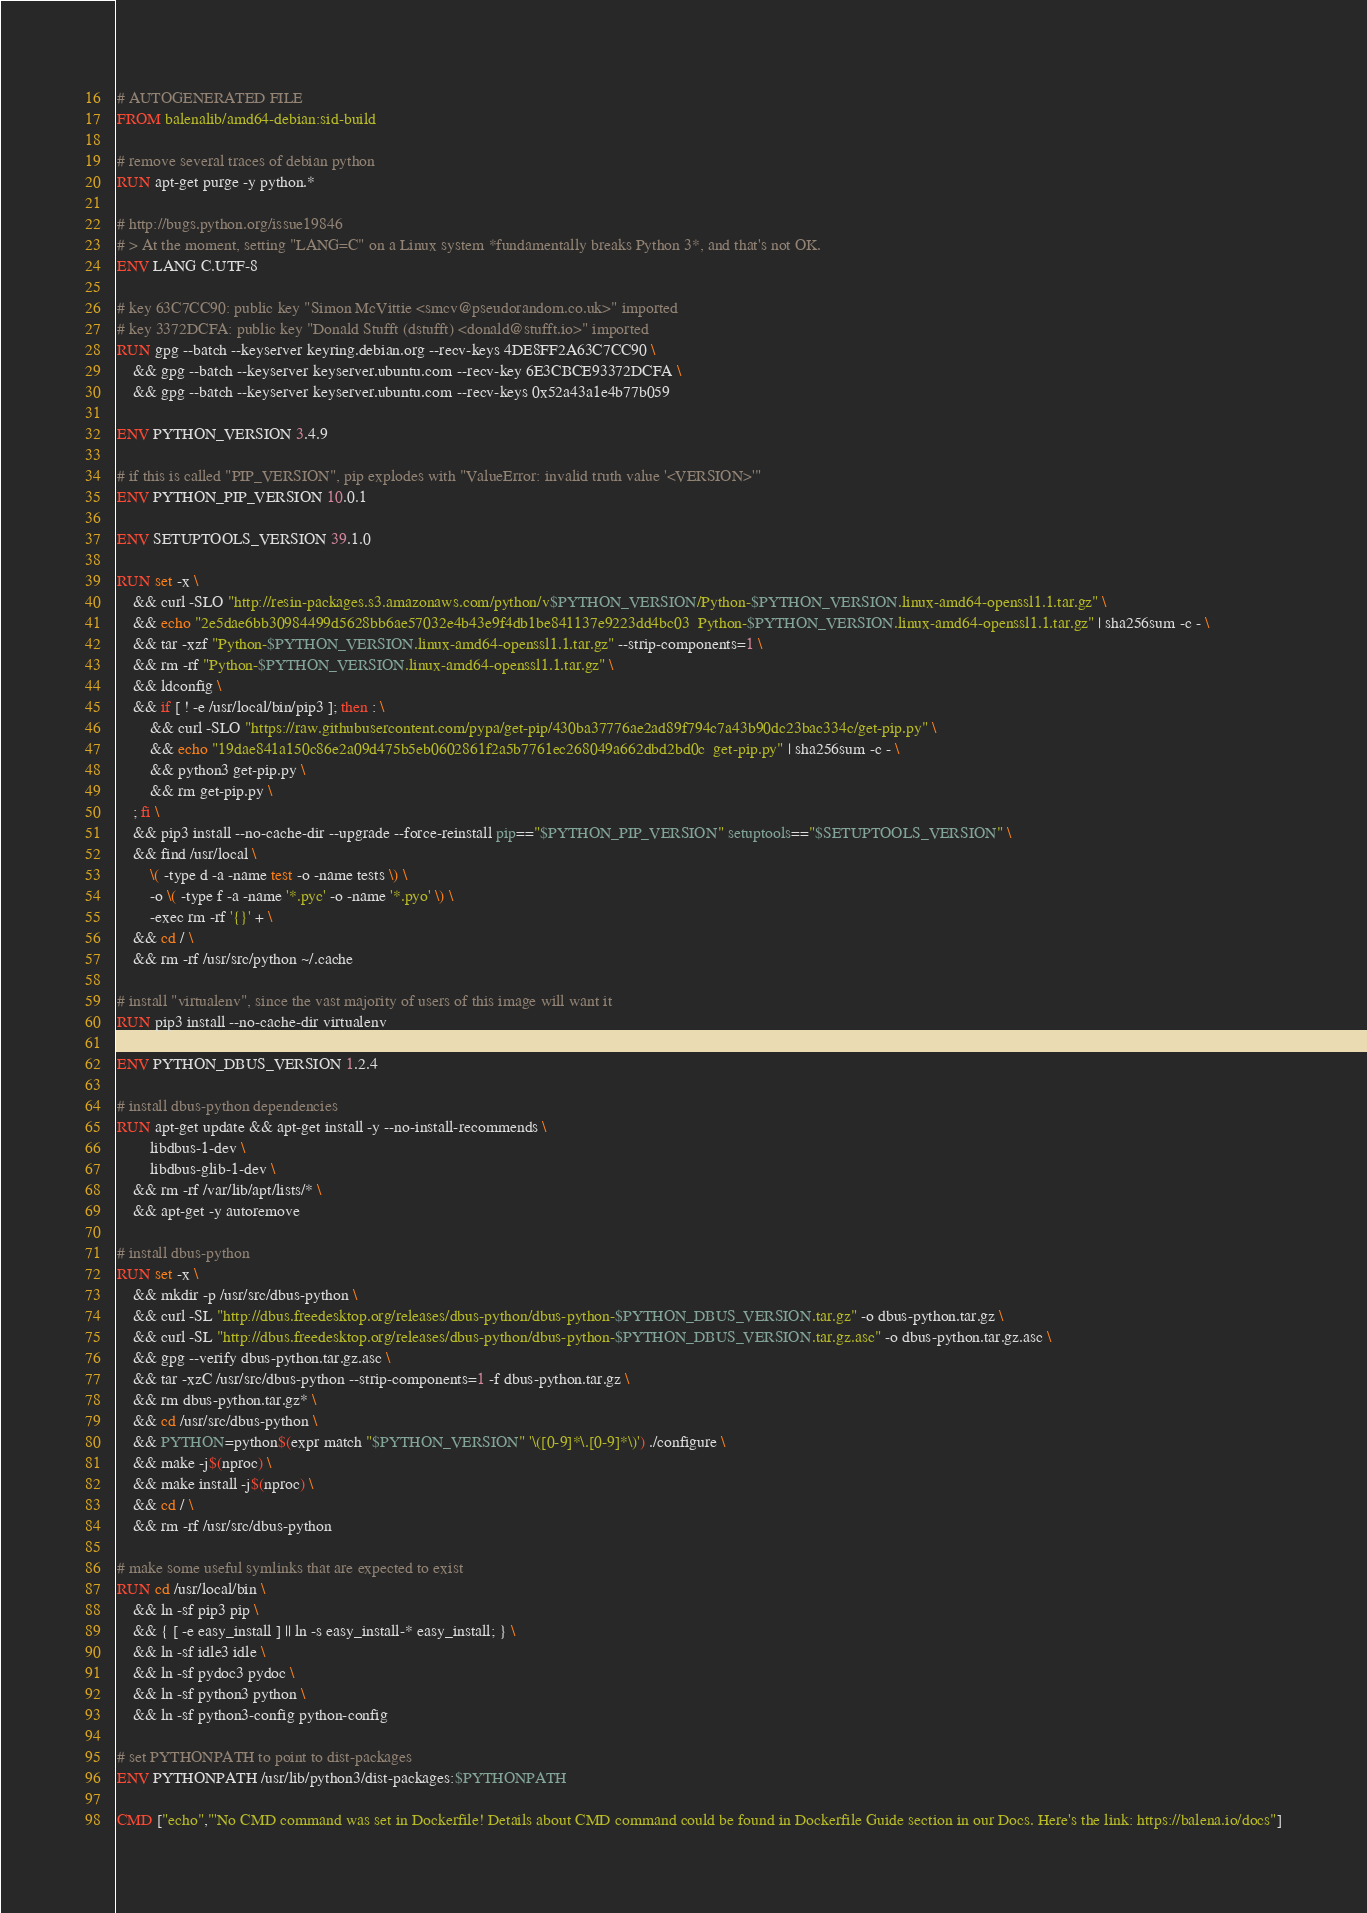<code> <loc_0><loc_0><loc_500><loc_500><_Dockerfile_># AUTOGENERATED FILE
FROM balenalib/amd64-debian:sid-build

# remove several traces of debian python
RUN apt-get purge -y python.*

# http://bugs.python.org/issue19846
# > At the moment, setting "LANG=C" on a Linux system *fundamentally breaks Python 3*, and that's not OK.
ENV LANG C.UTF-8

# key 63C7CC90: public key "Simon McVittie <smcv@pseudorandom.co.uk>" imported
# key 3372DCFA: public key "Donald Stufft (dstufft) <donald@stufft.io>" imported
RUN gpg --batch --keyserver keyring.debian.org --recv-keys 4DE8FF2A63C7CC90 \
	&& gpg --batch --keyserver keyserver.ubuntu.com --recv-key 6E3CBCE93372DCFA \
	&& gpg --batch --keyserver keyserver.ubuntu.com --recv-keys 0x52a43a1e4b77b059

ENV PYTHON_VERSION 3.4.9

# if this is called "PIP_VERSION", pip explodes with "ValueError: invalid truth value '<VERSION>'"
ENV PYTHON_PIP_VERSION 10.0.1

ENV SETUPTOOLS_VERSION 39.1.0

RUN set -x \
	&& curl -SLO "http://resin-packages.s3.amazonaws.com/python/v$PYTHON_VERSION/Python-$PYTHON_VERSION.linux-amd64-openssl1.1.tar.gz" \
	&& echo "2e5dae6bb30984499d5628bb6ae57032e4b43e9f4db1be841137e9223dd4bc03  Python-$PYTHON_VERSION.linux-amd64-openssl1.1.tar.gz" | sha256sum -c - \
	&& tar -xzf "Python-$PYTHON_VERSION.linux-amd64-openssl1.1.tar.gz" --strip-components=1 \
	&& rm -rf "Python-$PYTHON_VERSION.linux-amd64-openssl1.1.tar.gz" \
	&& ldconfig \
	&& if [ ! -e /usr/local/bin/pip3 ]; then : \
		&& curl -SLO "https://raw.githubusercontent.com/pypa/get-pip/430ba37776ae2ad89f794c7a43b90dc23bac334c/get-pip.py" \
		&& echo "19dae841a150c86e2a09d475b5eb0602861f2a5b7761ec268049a662dbd2bd0c  get-pip.py" | sha256sum -c - \
		&& python3 get-pip.py \
		&& rm get-pip.py \
	; fi \
	&& pip3 install --no-cache-dir --upgrade --force-reinstall pip=="$PYTHON_PIP_VERSION" setuptools=="$SETUPTOOLS_VERSION" \
	&& find /usr/local \
		\( -type d -a -name test -o -name tests \) \
		-o \( -type f -a -name '*.pyc' -o -name '*.pyo' \) \
		-exec rm -rf '{}' + \
	&& cd / \
	&& rm -rf /usr/src/python ~/.cache

# install "virtualenv", since the vast majority of users of this image will want it
RUN pip3 install --no-cache-dir virtualenv

ENV PYTHON_DBUS_VERSION 1.2.4

# install dbus-python dependencies 
RUN apt-get update && apt-get install -y --no-install-recommends \
		libdbus-1-dev \
		libdbus-glib-1-dev \
	&& rm -rf /var/lib/apt/lists/* \
	&& apt-get -y autoremove

# install dbus-python
RUN set -x \
	&& mkdir -p /usr/src/dbus-python \
	&& curl -SL "http://dbus.freedesktop.org/releases/dbus-python/dbus-python-$PYTHON_DBUS_VERSION.tar.gz" -o dbus-python.tar.gz \
	&& curl -SL "http://dbus.freedesktop.org/releases/dbus-python/dbus-python-$PYTHON_DBUS_VERSION.tar.gz.asc" -o dbus-python.tar.gz.asc \
	&& gpg --verify dbus-python.tar.gz.asc \
	&& tar -xzC /usr/src/dbus-python --strip-components=1 -f dbus-python.tar.gz \
	&& rm dbus-python.tar.gz* \
	&& cd /usr/src/dbus-python \
	&& PYTHON=python$(expr match "$PYTHON_VERSION" '\([0-9]*\.[0-9]*\)') ./configure \
	&& make -j$(nproc) \
	&& make install -j$(nproc) \
	&& cd / \
	&& rm -rf /usr/src/dbus-python

# make some useful symlinks that are expected to exist
RUN cd /usr/local/bin \
	&& ln -sf pip3 pip \
	&& { [ -e easy_install ] || ln -s easy_install-* easy_install; } \
	&& ln -sf idle3 idle \
	&& ln -sf pydoc3 pydoc \
	&& ln -sf python3 python \
	&& ln -sf python3-config python-config

# set PYTHONPATH to point to dist-packages
ENV PYTHONPATH /usr/lib/python3/dist-packages:$PYTHONPATH

CMD ["echo","'No CMD command was set in Dockerfile! Details about CMD command could be found in Dockerfile Guide section in our Docs. Here's the link: https://balena.io/docs"]</code> 